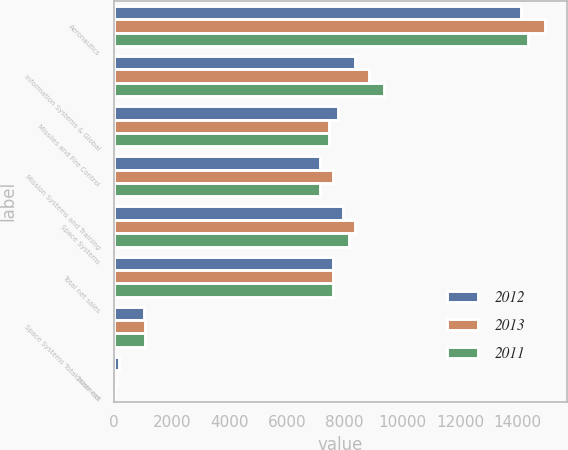Convert chart to OTSL. <chart><loc_0><loc_0><loc_500><loc_500><stacked_bar_chart><ecel><fcel>Aeronautics<fcel>Information Systems & Global<fcel>Missiles and Fire Control<fcel>Mission Systems and Training<fcel>Space Systems<fcel>Total net sales<fcel>Space Systems Total business<fcel>Other net<nl><fcel>2012<fcel>14123<fcel>8367<fcel>7757<fcel>7153<fcel>7958<fcel>7579<fcel>1045<fcel>180<nl><fcel>2013<fcel>14953<fcel>8846<fcel>7457<fcel>7579<fcel>8347<fcel>7579<fcel>1083<fcel>104<nl><fcel>2011<fcel>14362<fcel>9381<fcel>7463<fcel>7132<fcel>8161<fcel>7579<fcel>1063<fcel>46<nl></chart> 